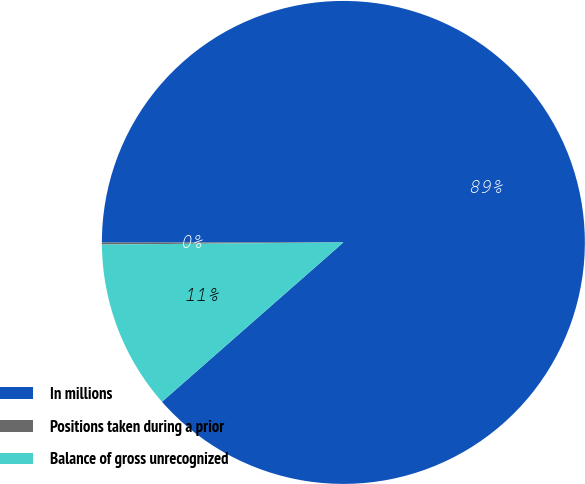Convert chart to OTSL. <chart><loc_0><loc_0><loc_500><loc_500><pie_chart><fcel>In millions<fcel>Positions taken during a prior<fcel>Balance of gross unrecognized<nl><fcel>88.54%<fcel>0.13%<fcel>11.33%<nl></chart> 